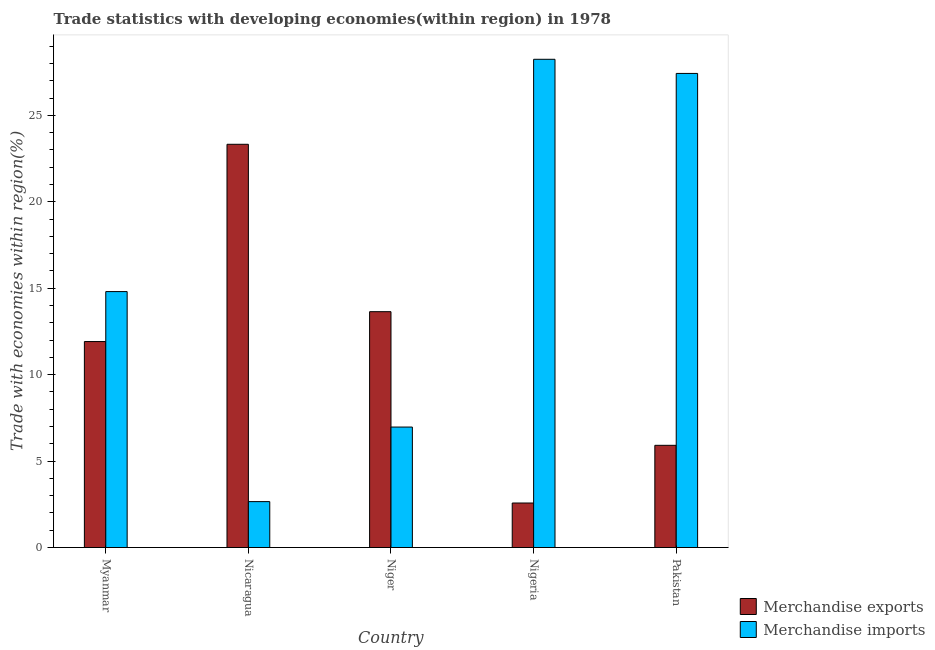How many groups of bars are there?
Your answer should be compact. 5. Are the number of bars per tick equal to the number of legend labels?
Give a very brief answer. Yes. How many bars are there on the 3rd tick from the left?
Give a very brief answer. 2. What is the label of the 1st group of bars from the left?
Offer a terse response. Myanmar. What is the merchandise exports in Nicaragua?
Make the answer very short. 23.33. Across all countries, what is the maximum merchandise imports?
Offer a terse response. 28.25. Across all countries, what is the minimum merchandise imports?
Ensure brevity in your answer.  2.66. In which country was the merchandise imports maximum?
Provide a succinct answer. Nigeria. In which country was the merchandise exports minimum?
Your answer should be very brief. Nigeria. What is the total merchandise exports in the graph?
Make the answer very short. 57.38. What is the difference between the merchandise imports in Myanmar and that in Niger?
Your response must be concise. 7.84. What is the difference between the merchandise exports in Myanmar and the merchandise imports in Nigeria?
Offer a very short reply. -16.33. What is the average merchandise exports per country?
Ensure brevity in your answer.  11.48. What is the difference between the merchandise imports and merchandise exports in Myanmar?
Offer a very short reply. 2.89. In how many countries, is the merchandise imports greater than 5 %?
Keep it short and to the point. 4. What is the ratio of the merchandise exports in Niger to that in Nigeria?
Your answer should be very brief. 5.3. Is the merchandise exports in Niger less than that in Pakistan?
Your response must be concise. No. What is the difference between the highest and the second highest merchandise exports?
Offer a very short reply. 9.68. What is the difference between the highest and the lowest merchandise exports?
Provide a succinct answer. 20.75. In how many countries, is the merchandise imports greater than the average merchandise imports taken over all countries?
Provide a succinct answer. 2. How many bars are there?
Provide a succinct answer. 10. How many countries are there in the graph?
Your response must be concise. 5. What is the difference between two consecutive major ticks on the Y-axis?
Make the answer very short. 5. Does the graph contain grids?
Keep it short and to the point. No. How are the legend labels stacked?
Provide a short and direct response. Vertical. What is the title of the graph?
Offer a terse response. Trade statistics with developing economies(within region) in 1978. What is the label or title of the X-axis?
Keep it short and to the point. Country. What is the label or title of the Y-axis?
Keep it short and to the point. Trade with economies within region(%). What is the Trade with economies within region(%) in Merchandise exports in Myanmar?
Provide a succinct answer. 11.92. What is the Trade with economies within region(%) of Merchandise imports in Myanmar?
Ensure brevity in your answer.  14.81. What is the Trade with economies within region(%) in Merchandise exports in Nicaragua?
Keep it short and to the point. 23.33. What is the Trade with economies within region(%) in Merchandise imports in Nicaragua?
Ensure brevity in your answer.  2.66. What is the Trade with economies within region(%) in Merchandise exports in Niger?
Your answer should be very brief. 13.64. What is the Trade with economies within region(%) in Merchandise imports in Niger?
Give a very brief answer. 6.97. What is the Trade with economies within region(%) of Merchandise exports in Nigeria?
Offer a terse response. 2.58. What is the Trade with economies within region(%) in Merchandise imports in Nigeria?
Provide a short and direct response. 28.25. What is the Trade with economies within region(%) in Merchandise exports in Pakistan?
Keep it short and to the point. 5.91. What is the Trade with economies within region(%) of Merchandise imports in Pakistan?
Your answer should be very brief. 27.43. Across all countries, what is the maximum Trade with economies within region(%) of Merchandise exports?
Keep it short and to the point. 23.33. Across all countries, what is the maximum Trade with economies within region(%) of Merchandise imports?
Offer a very short reply. 28.25. Across all countries, what is the minimum Trade with economies within region(%) of Merchandise exports?
Ensure brevity in your answer.  2.58. Across all countries, what is the minimum Trade with economies within region(%) of Merchandise imports?
Provide a short and direct response. 2.66. What is the total Trade with economies within region(%) in Merchandise exports in the graph?
Give a very brief answer. 57.38. What is the total Trade with economies within region(%) of Merchandise imports in the graph?
Give a very brief answer. 80.11. What is the difference between the Trade with economies within region(%) of Merchandise exports in Myanmar and that in Nicaragua?
Keep it short and to the point. -11.41. What is the difference between the Trade with economies within region(%) in Merchandise imports in Myanmar and that in Nicaragua?
Give a very brief answer. 12.15. What is the difference between the Trade with economies within region(%) in Merchandise exports in Myanmar and that in Niger?
Offer a very short reply. -1.73. What is the difference between the Trade with economies within region(%) of Merchandise imports in Myanmar and that in Niger?
Provide a short and direct response. 7.84. What is the difference between the Trade with economies within region(%) of Merchandise exports in Myanmar and that in Nigeria?
Offer a very short reply. 9.34. What is the difference between the Trade with economies within region(%) in Merchandise imports in Myanmar and that in Nigeria?
Ensure brevity in your answer.  -13.44. What is the difference between the Trade with economies within region(%) in Merchandise exports in Myanmar and that in Pakistan?
Your response must be concise. 6. What is the difference between the Trade with economies within region(%) of Merchandise imports in Myanmar and that in Pakistan?
Your answer should be very brief. -12.62. What is the difference between the Trade with economies within region(%) in Merchandise exports in Nicaragua and that in Niger?
Offer a terse response. 9.68. What is the difference between the Trade with economies within region(%) in Merchandise imports in Nicaragua and that in Niger?
Offer a terse response. -4.31. What is the difference between the Trade with economies within region(%) in Merchandise exports in Nicaragua and that in Nigeria?
Make the answer very short. 20.75. What is the difference between the Trade with economies within region(%) in Merchandise imports in Nicaragua and that in Nigeria?
Keep it short and to the point. -25.59. What is the difference between the Trade with economies within region(%) of Merchandise exports in Nicaragua and that in Pakistan?
Offer a very short reply. 17.42. What is the difference between the Trade with economies within region(%) in Merchandise imports in Nicaragua and that in Pakistan?
Offer a very short reply. -24.77. What is the difference between the Trade with economies within region(%) of Merchandise exports in Niger and that in Nigeria?
Provide a succinct answer. 11.07. What is the difference between the Trade with economies within region(%) of Merchandise imports in Niger and that in Nigeria?
Ensure brevity in your answer.  -21.28. What is the difference between the Trade with economies within region(%) in Merchandise exports in Niger and that in Pakistan?
Your response must be concise. 7.73. What is the difference between the Trade with economies within region(%) of Merchandise imports in Niger and that in Pakistan?
Your answer should be very brief. -20.46. What is the difference between the Trade with economies within region(%) in Merchandise exports in Nigeria and that in Pakistan?
Provide a short and direct response. -3.34. What is the difference between the Trade with economies within region(%) of Merchandise imports in Nigeria and that in Pakistan?
Give a very brief answer. 0.82. What is the difference between the Trade with economies within region(%) in Merchandise exports in Myanmar and the Trade with economies within region(%) in Merchandise imports in Nicaragua?
Make the answer very short. 9.26. What is the difference between the Trade with economies within region(%) of Merchandise exports in Myanmar and the Trade with economies within region(%) of Merchandise imports in Niger?
Your answer should be very brief. 4.95. What is the difference between the Trade with economies within region(%) in Merchandise exports in Myanmar and the Trade with economies within region(%) in Merchandise imports in Nigeria?
Give a very brief answer. -16.33. What is the difference between the Trade with economies within region(%) of Merchandise exports in Myanmar and the Trade with economies within region(%) of Merchandise imports in Pakistan?
Your answer should be compact. -15.51. What is the difference between the Trade with economies within region(%) in Merchandise exports in Nicaragua and the Trade with economies within region(%) in Merchandise imports in Niger?
Keep it short and to the point. 16.36. What is the difference between the Trade with economies within region(%) in Merchandise exports in Nicaragua and the Trade with economies within region(%) in Merchandise imports in Nigeria?
Offer a terse response. -4.92. What is the difference between the Trade with economies within region(%) of Merchandise exports in Nicaragua and the Trade with economies within region(%) of Merchandise imports in Pakistan?
Make the answer very short. -4.1. What is the difference between the Trade with economies within region(%) of Merchandise exports in Niger and the Trade with economies within region(%) of Merchandise imports in Nigeria?
Your answer should be very brief. -14.6. What is the difference between the Trade with economies within region(%) of Merchandise exports in Niger and the Trade with economies within region(%) of Merchandise imports in Pakistan?
Ensure brevity in your answer.  -13.78. What is the difference between the Trade with economies within region(%) in Merchandise exports in Nigeria and the Trade with economies within region(%) in Merchandise imports in Pakistan?
Your answer should be very brief. -24.85. What is the average Trade with economies within region(%) of Merchandise exports per country?
Give a very brief answer. 11.48. What is the average Trade with economies within region(%) of Merchandise imports per country?
Ensure brevity in your answer.  16.02. What is the difference between the Trade with economies within region(%) in Merchandise exports and Trade with economies within region(%) in Merchandise imports in Myanmar?
Provide a succinct answer. -2.89. What is the difference between the Trade with economies within region(%) of Merchandise exports and Trade with economies within region(%) of Merchandise imports in Nicaragua?
Provide a short and direct response. 20.67. What is the difference between the Trade with economies within region(%) of Merchandise exports and Trade with economies within region(%) of Merchandise imports in Niger?
Your answer should be very brief. 6.68. What is the difference between the Trade with economies within region(%) of Merchandise exports and Trade with economies within region(%) of Merchandise imports in Nigeria?
Your answer should be very brief. -25.67. What is the difference between the Trade with economies within region(%) in Merchandise exports and Trade with economies within region(%) in Merchandise imports in Pakistan?
Your response must be concise. -21.52. What is the ratio of the Trade with economies within region(%) in Merchandise exports in Myanmar to that in Nicaragua?
Make the answer very short. 0.51. What is the ratio of the Trade with economies within region(%) in Merchandise imports in Myanmar to that in Nicaragua?
Your answer should be compact. 5.57. What is the ratio of the Trade with economies within region(%) of Merchandise exports in Myanmar to that in Niger?
Ensure brevity in your answer.  0.87. What is the ratio of the Trade with economies within region(%) in Merchandise imports in Myanmar to that in Niger?
Your answer should be compact. 2.12. What is the ratio of the Trade with economies within region(%) of Merchandise exports in Myanmar to that in Nigeria?
Provide a succinct answer. 4.63. What is the ratio of the Trade with economies within region(%) in Merchandise imports in Myanmar to that in Nigeria?
Provide a short and direct response. 0.52. What is the ratio of the Trade with economies within region(%) of Merchandise exports in Myanmar to that in Pakistan?
Ensure brevity in your answer.  2.02. What is the ratio of the Trade with economies within region(%) of Merchandise imports in Myanmar to that in Pakistan?
Offer a terse response. 0.54. What is the ratio of the Trade with economies within region(%) in Merchandise exports in Nicaragua to that in Niger?
Ensure brevity in your answer.  1.71. What is the ratio of the Trade with economies within region(%) in Merchandise imports in Nicaragua to that in Niger?
Make the answer very short. 0.38. What is the ratio of the Trade with economies within region(%) in Merchandise exports in Nicaragua to that in Nigeria?
Provide a short and direct response. 9.06. What is the ratio of the Trade with economies within region(%) in Merchandise imports in Nicaragua to that in Nigeria?
Provide a succinct answer. 0.09. What is the ratio of the Trade with economies within region(%) of Merchandise exports in Nicaragua to that in Pakistan?
Offer a very short reply. 3.95. What is the ratio of the Trade with economies within region(%) of Merchandise imports in Nicaragua to that in Pakistan?
Offer a very short reply. 0.1. What is the ratio of the Trade with economies within region(%) of Merchandise exports in Niger to that in Nigeria?
Provide a short and direct response. 5.3. What is the ratio of the Trade with economies within region(%) of Merchandise imports in Niger to that in Nigeria?
Ensure brevity in your answer.  0.25. What is the ratio of the Trade with economies within region(%) in Merchandise exports in Niger to that in Pakistan?
Ensure brevity in your answer.  2.31. What is the ratio of the Trade with economies within region(%) in Merchandise imports in Niger to that in Pakistan?
Your answer should be compact. 0.25. What is the ratio of the Trade with economies within region(%) in Merchandise exports in Nigeria to that in Pakistan?
Provide a short and direct response. 0.44. What is the ratio of the Trade with economies within region(%) of Merchandise imports in Nigeria to that in Pakistan?
Give a very brief answer. 1.03. What is the difference between the highest and the second highest Trade with economies within region(%) in Merchandise exports?
Make the answer very short. 9.68. What is the difference between the highest and the second highest Trade with economies within region(%) of Merchandise imports?
Provide a short and direct response. 0.82. What is the difference between the highest and the lowest Trade with economies within region(%) of Merchandise exports?
Provide a short and direct response. 20.75. What is the difference between the highest and the lowest Trade with economies within region(%) of Merchandise imports?
Give a very brief answer. 25.59. 